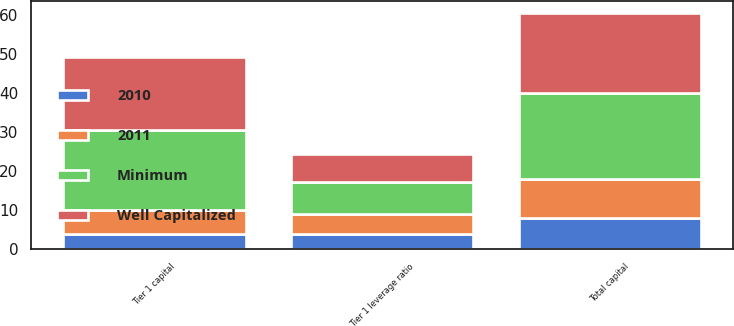Convert chart to OTSL. <chart><loc_0><loc_0><loc_500><loc_500><stacked_bar_chart><ecel><fcel>Tier 1 capital<fcel>Total capital<fcel>Tier 1 leverage ratio<nl><fcel>2010<fcel>4<fcel>8<fcel>4<nl><fcel>2011<fcel>6<fcel>10<fcel>5<nl><fcel>Well Capitalized<fcel>18.8<fcel>20.5<fcel>7.3<nl><fcel>Minimum<fcel>20.5<fcel>22<fcel>8.2<nl></chart> 